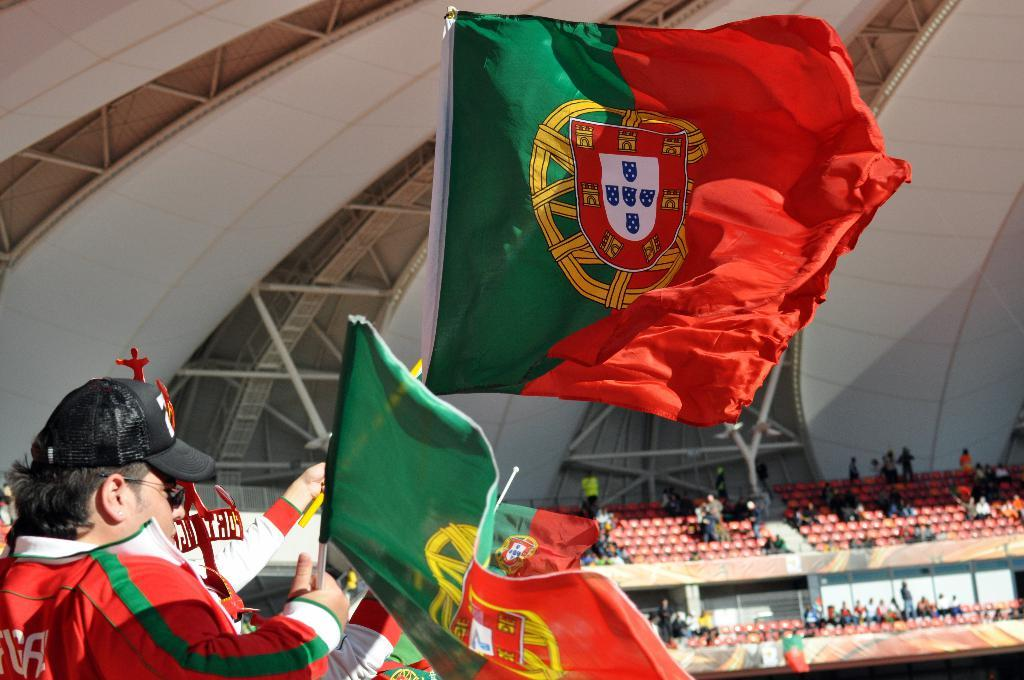What are the people in the image doing? The people in the image are sitting on chairs. Where are the chairs located? The chairs are in a stadium. What are some people holding in their hands? Some people are holding flags in their hands. What can be seen in the background of the image? There are iron grills in the background of the image. How many pizzas are being served to the people in the image? There is no mention of pizzas in the image; the people are holding flags. Can you tell me how many toes are visible on the people in the image? The image does not show the toes of the people; it only shows them sitting on chairs and holding flags. 